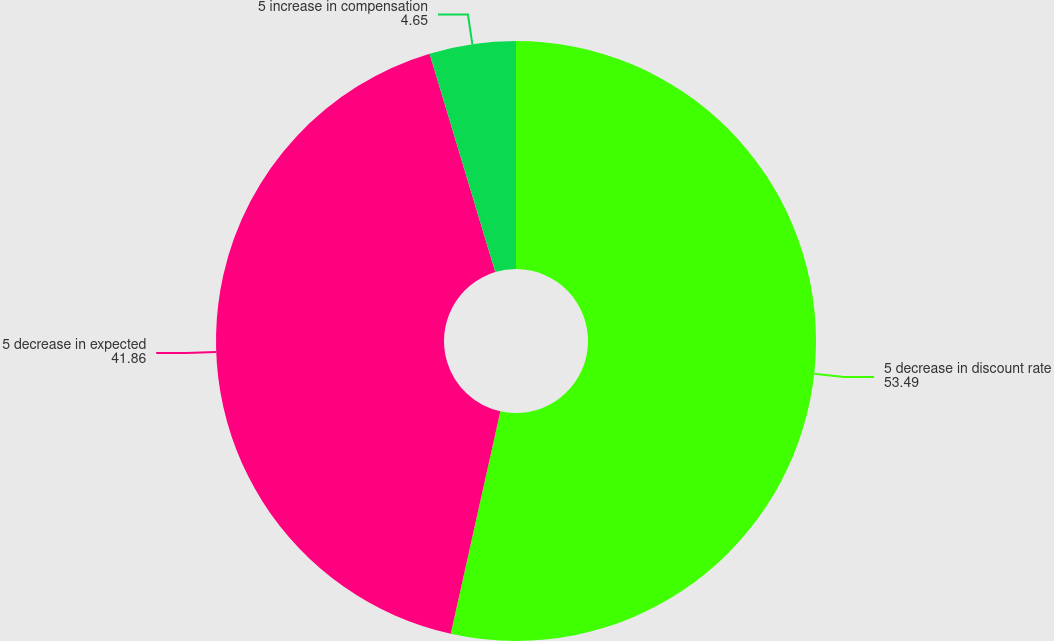Convert chart. <chart><loc_0><loc_0><loc_500><loc_500><pie_chart><fcel>5 decrease in discount rate<fcel>5 decrease in expected<fcel>5 increase in compensation<nl><fcel>53.49%<fcel>41.86%<fcel>4.65%<nl></chart> 